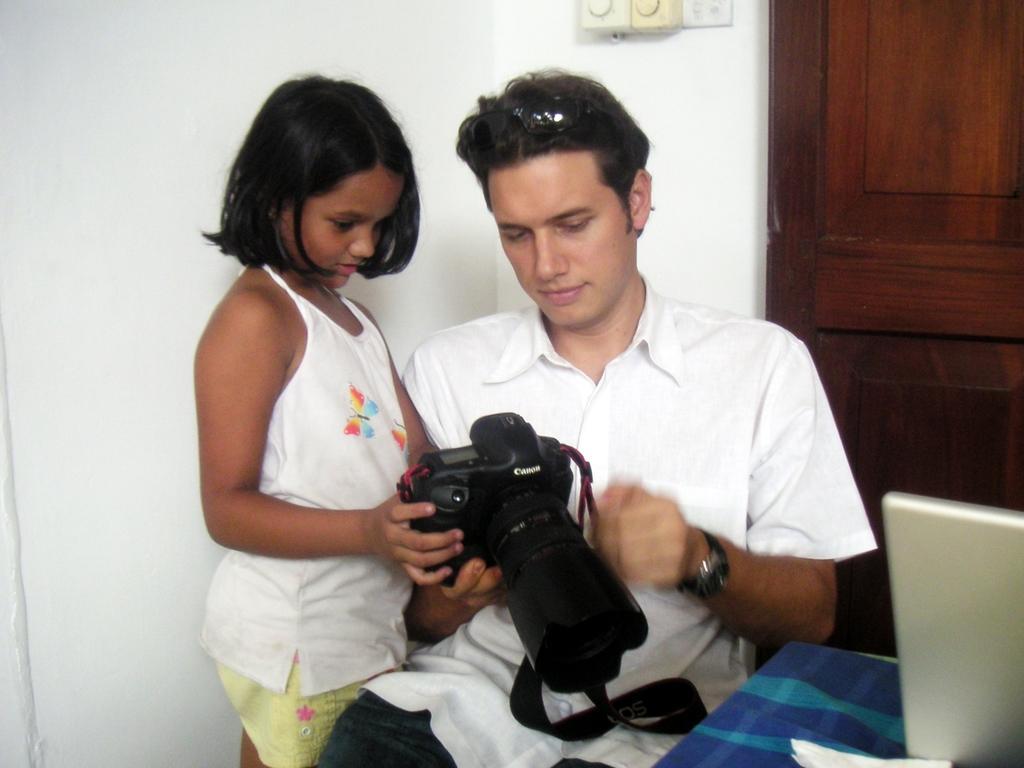Describe this image in one or two sentences. In the image we can see there are people who are present and they are holding a camera in their hand. The man is sitting and the girl is standing and at the back the wall is in white colour. 